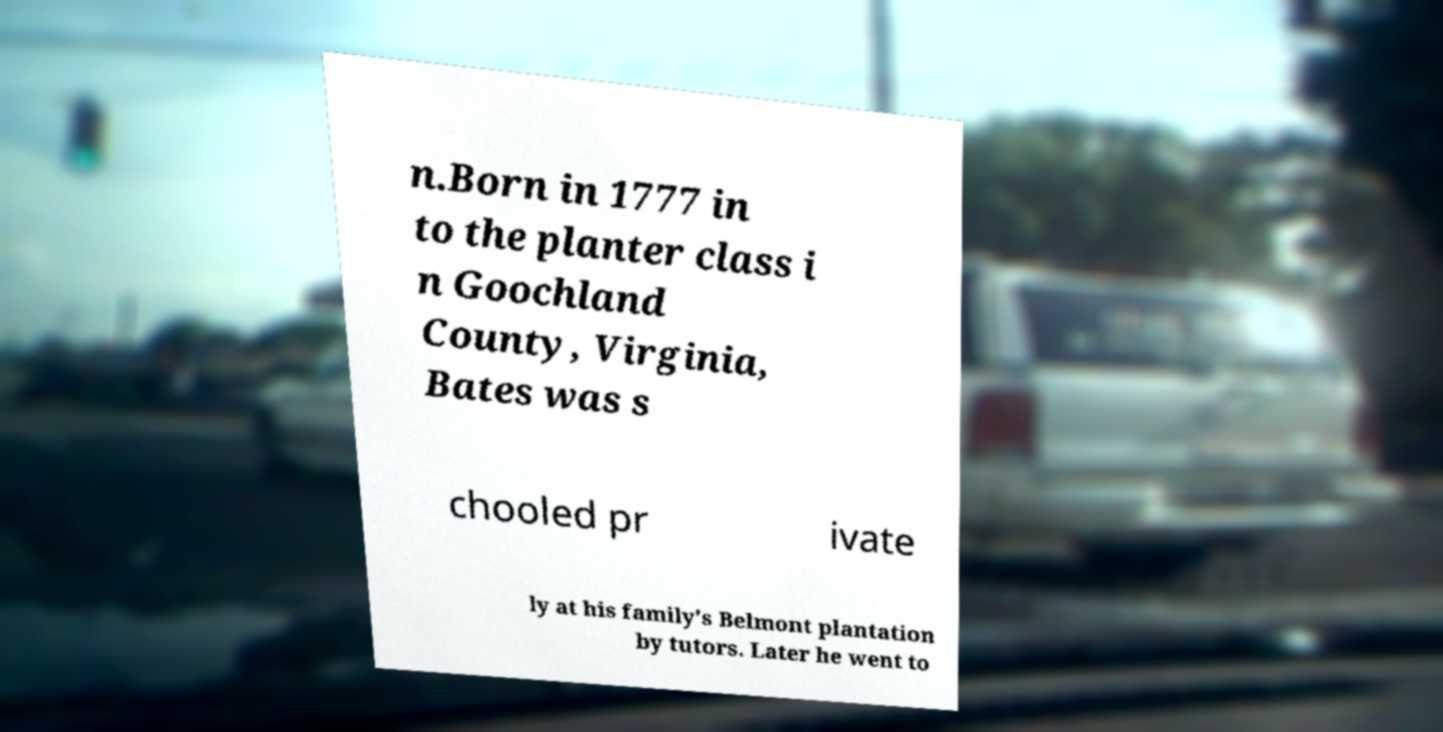Please read and relay the text visible in this image. What does it say? n.Born in 1777 in to the planter class i n Goochland County, Virginia, Bates was s chooled pr ivate ly at his family's Belmont plantation by tutors. Later he went to 